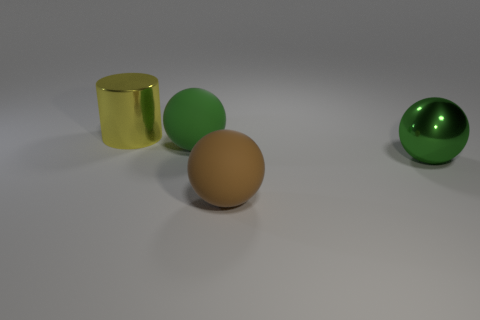How many big green things have the same material as the large brown sphere?
Your answer should be very brief. 1. What color is the big object that is made of the same material as the brown ball?
Offer a very short reply. Green. What shape is the green matte object?
Your answer should be compact. Sphere. What number of other cylinders have the same color as the big cylinder?
Your response must be concise. 0. There is a yellow metallic thing that is the same size as the metallic sphere; what shape is it?
Make the answer very short. Cylinder. Is there a matte thing of the same size as the green metal ball?
Offer a very short reply. Yes. What is the material of the brown object that is the same size as the yellow thing?
Offer a terse response. Rubber. There is a rubber thing behind the big shiny thing that is on the right side of the yellow cylinder; how big is it?
Provide a short and direct response. Large. There is a shiny object in front of the cylinder; does it have the same size as the green matte sphere?
Your response must be concise. Yes. Are there more big metallic balls behind the large cylinder than large yellow things that are in front of the large brown sphere?
Give a very brief answer. No. 